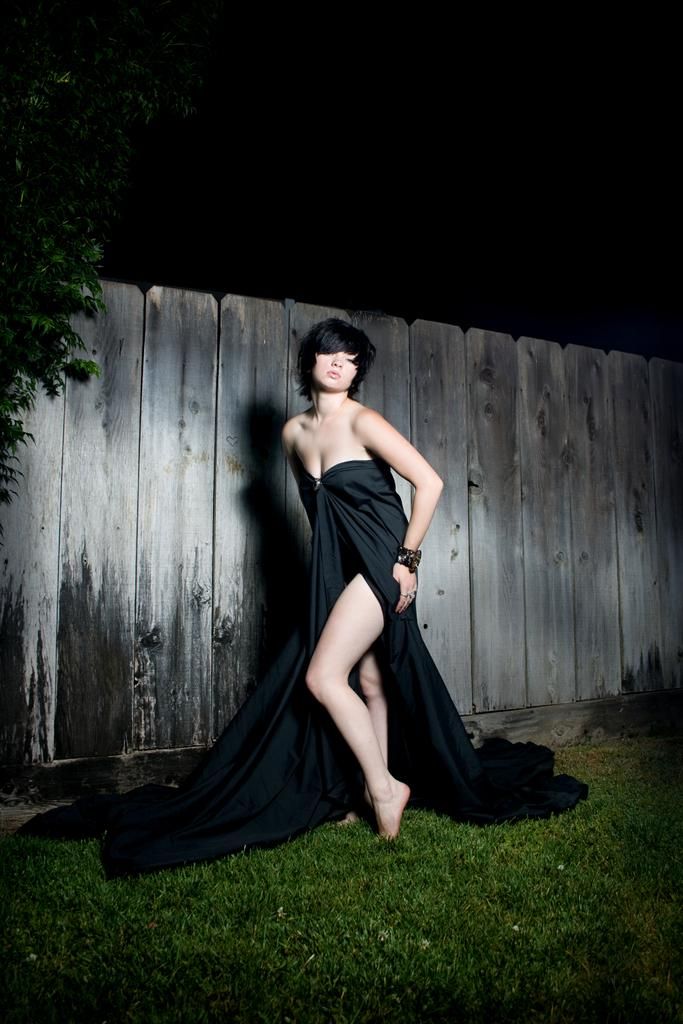Who is present in the image? There is a woman in the image. What is the woman wearing? The woman is wearing a black dress. What is the woman's position in the image? The woman is standing on the ground. What type of vegetation can be seen in the image? There is grass in the image. What structures are visible in the image? There is a tree and a wall in the image. How would you describe the lighting in the image? The background of the image is dark. Can you see any fairies flying around the woman in the image? There are no fairies present in the image. Is the woman swimming in the image? The woman is standing on the ground, not swimming. 